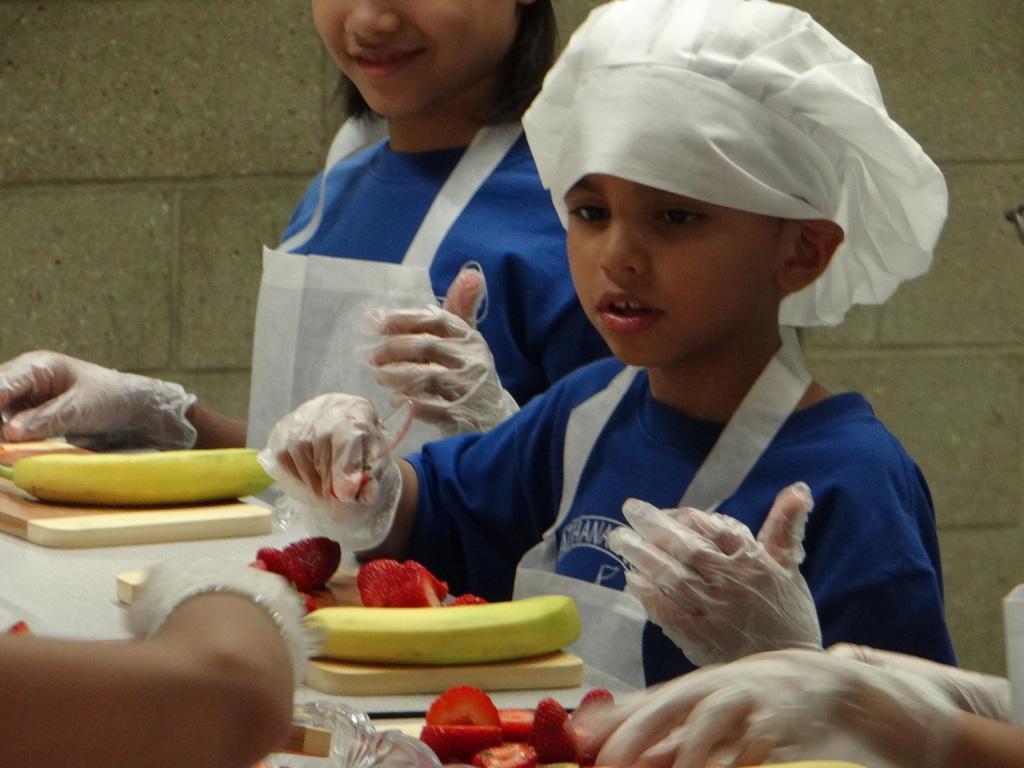Describe this image in one or two sentences. In this image we can see persons standing in front of the table, on the table, we can see bananas, strawberries and some other objects, in the background we can see the wall. 